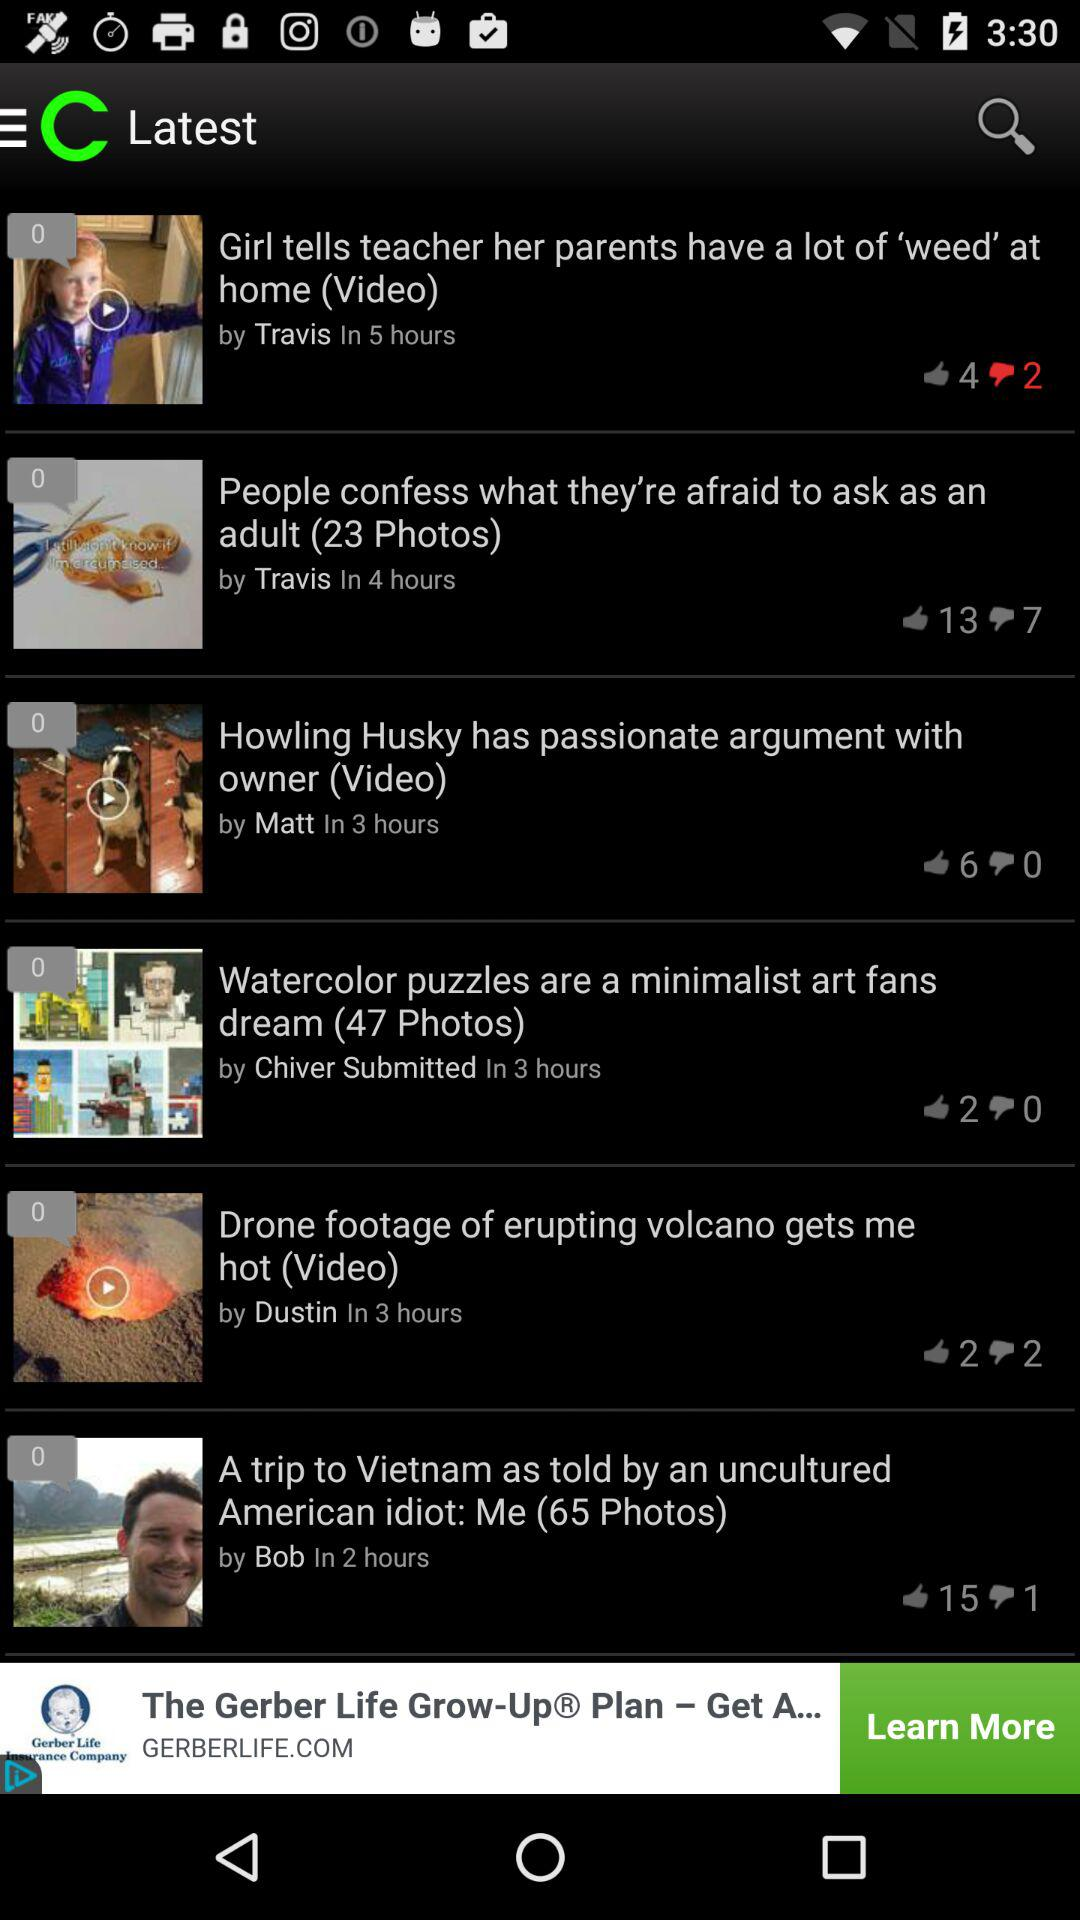In which article 23 photos are present? 23 photos are present in the article "People confess what they're afraid to ask as an adult". 